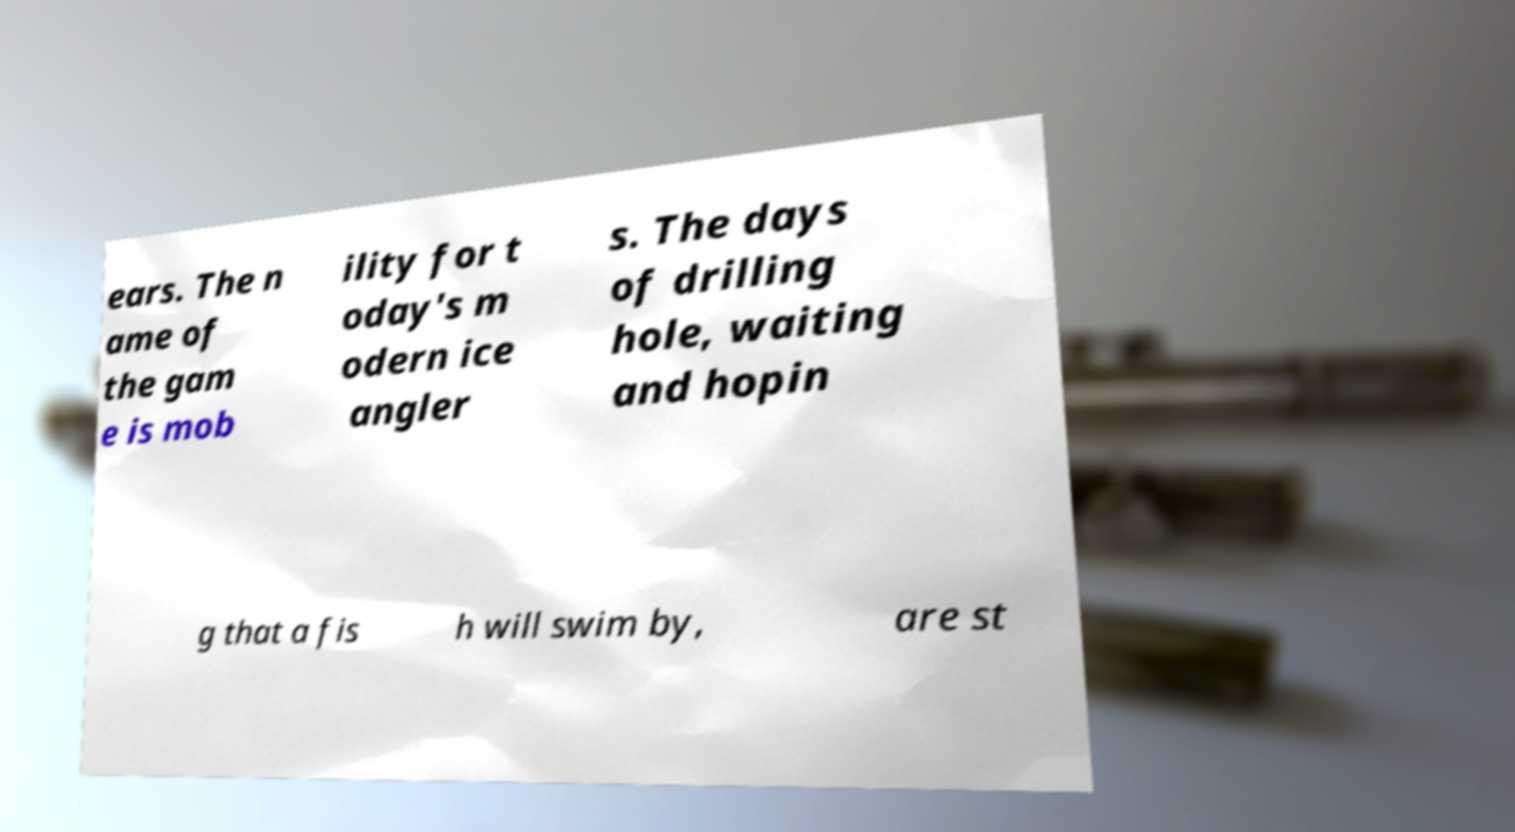I need the written content from this picture converted into text. Can you do that? ears. The n ame of the gam e is mob ility for t oday's m odern ice angler s. The days of drilling hole, waiting and hopin g that a fis h will swim by, are st 